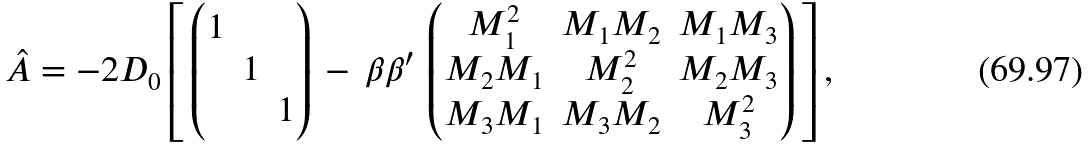<formula> <loc_0><loc_0><loc_500><loc_500>\hat { A } = - 2 D _ { 0 } \left [ \, \begin{pmatrix} 1 & & \\ & 1 & \\ & & 1 \end{pmatrix} \, - \, \beta \beta ^ { \prime } \, \begin{pmatrix} M _ { 1 } ^ { 2 } & M _ { 1 } M _ { 2 } & M _ { 1 } M _ { 3 } \\ M _ { 2 } M _ { 1 } & M _ { 2 } ^ { 2 } & M _ { 2 } M _ { 3 } \\ M _ { 3 } M _ { 1 } & M _ { 3 } M _ { 2 } & M _ { 3 } ^ { 2 } \end{pmatrix} \, \right ] ,</formula> 